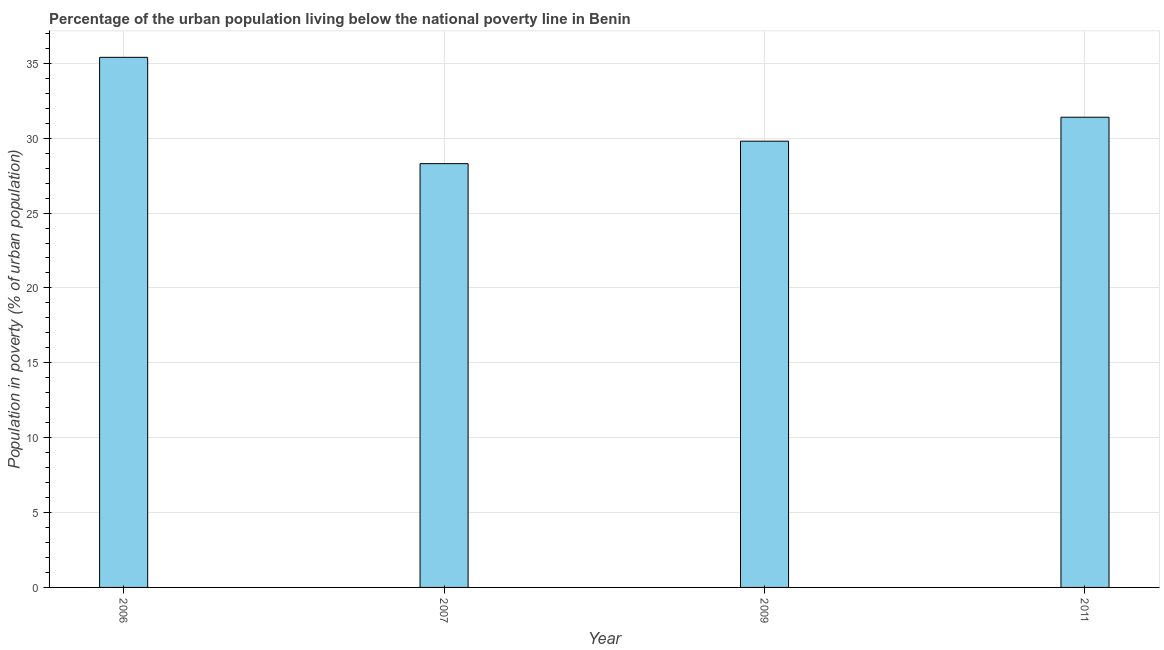What is the title of the graph?
Keep it short and to the point. Percentage of the urban population living below the national poverty line in Benin. What is the label or title of the Y-axis?
Offer a very short reply. Population in poverty (% of urban population). What is the percentage of urban population living below poverty line in 2006?
Ensure brevity in your answer.  35.4. Across all years, what is the maximum percentage of urban population living below poverty line?
Provide a short and direct response. 35.4. Across all years, what is the minimum percentage of urban population living below poverty line?
Your answer should be very brief. 28.3. In which year was the percentage of urban population living below poverty line minimum?
Offer a terse response. 2007. What is the sum of the percentage of urban population living below poverty line?
Keep it short and to the point. 124.9. What is the average percentage of urban population living below poverty line per year?
Ensure brevity in your answer.  31.23. What is the median percentage of urban population living below poverty line?
Offer a very short reply. 30.6. What is the ratio of the percentage of urban population living below poverty line in 2006 to that in 2007?
Make the answer very short. 1.25. Is the percentage of urban population living below poverty line in 2007 less than that in 2011?
Provide a short and direct response. Yes. Is the difference between the percentage of urban population living below poverty line in 2006 and 2007 greater than the difference between any two years?
Offer a very short reply. Yes. Is the sum of the percentage of urban population living below poverty line in 2006 and 2009 greater than the maximum percentage of urban population living below poverty line across all years?
Give a very brief answer. Yes. In how many years, is the percentage of urban population living below poverty line greater than the average percentage of urban population living below poverty line taken over all years?
Keep it short and to the point. 2. How many years are there in the graph?
Keep it short and to the point. 4. What is the Population in poverty (% of urban population) of 2006?
Provide a short and direct response. 35.4. What is the Population in poverty (% of urban population) of 2007?
Your answer should be very brief. 28.3. What is the Population in poverty (% of urban population) in 2009?
Offer a terse response. 29.8. What is the Population in poverty (% of urban population) of 2011?
Provide a short and direct response. 31.4. What is the difference between the Population in poverty (% of urban population) in 2006 and 2007?
Your response must be concise. 7.1. What is the difference between the Population in poverty (% of urban population) in 2007 and 2009?
Your response must be concise. -1.5. What is the ratio of the Population in poverty (% of urban population) in 2006 to that in 2007?
Keep it short and to the point. 1.25. What is the ratio of the Population in poverty (% of urban population) in 2006 to that in 2009?
Offer a terse response. 1.19. What is the ratio of the Population in poverty (% of urban population) in 2006 to that in 2011?
Offer a terse response. 1.13. What is the ratio of the Population in poverty (% of urban population) in 2007 to that in 2009?
Ensure brevity in your answer.  0.95. What is the ratio of the Population in poverty (% of urban population) in 2007 to that in 2011?
Make the answer very short. 0.9. What is the ratio of the Population in poverty (% of urban population) in 2009 to that in 2011?
Provide a succinct answer. 0.95. 